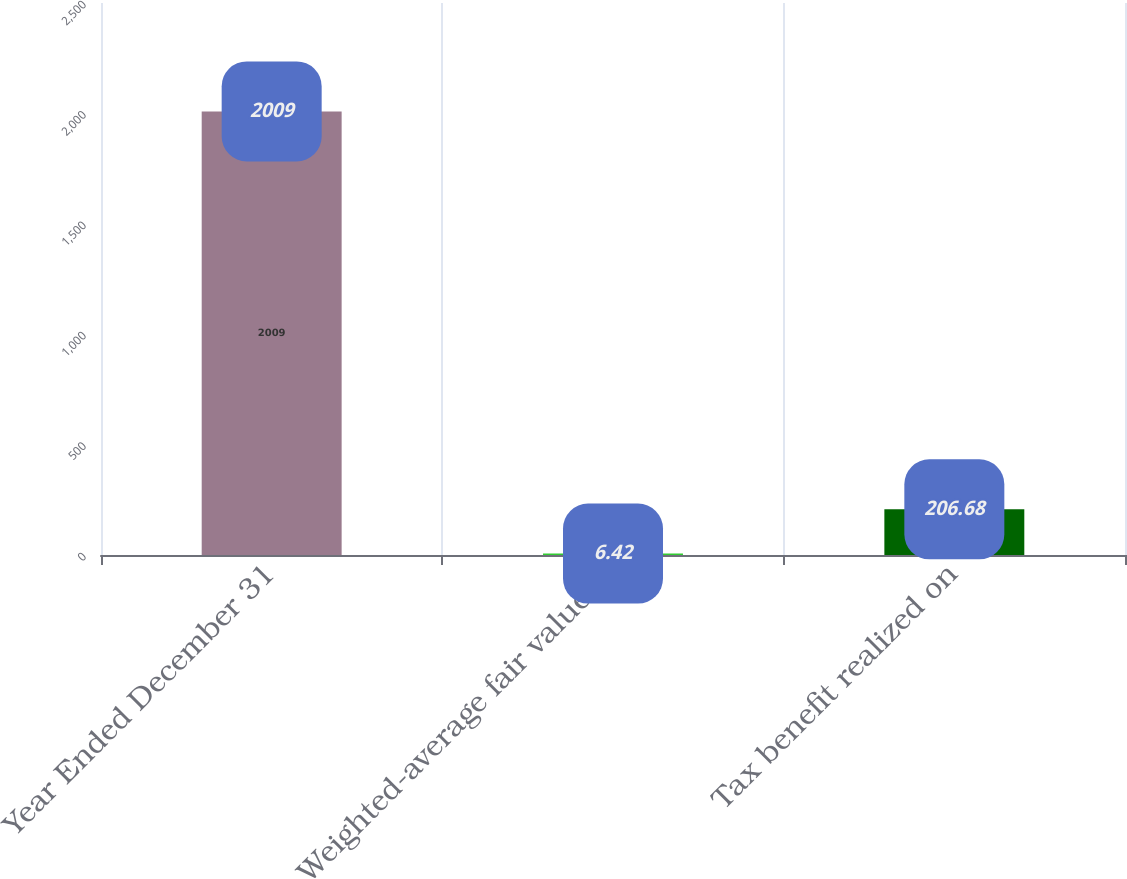Convert chart to OTSL. <chart><loc_0><loc_0><loc_500><loc_500><bar_chart><fcel>Year Ended December 31<fcel>Weighted-average fair value of<fcel>Tax benefit realized on<nl><fcel>2009<fcel>6.42<fcel>206.68<nl></chart> 